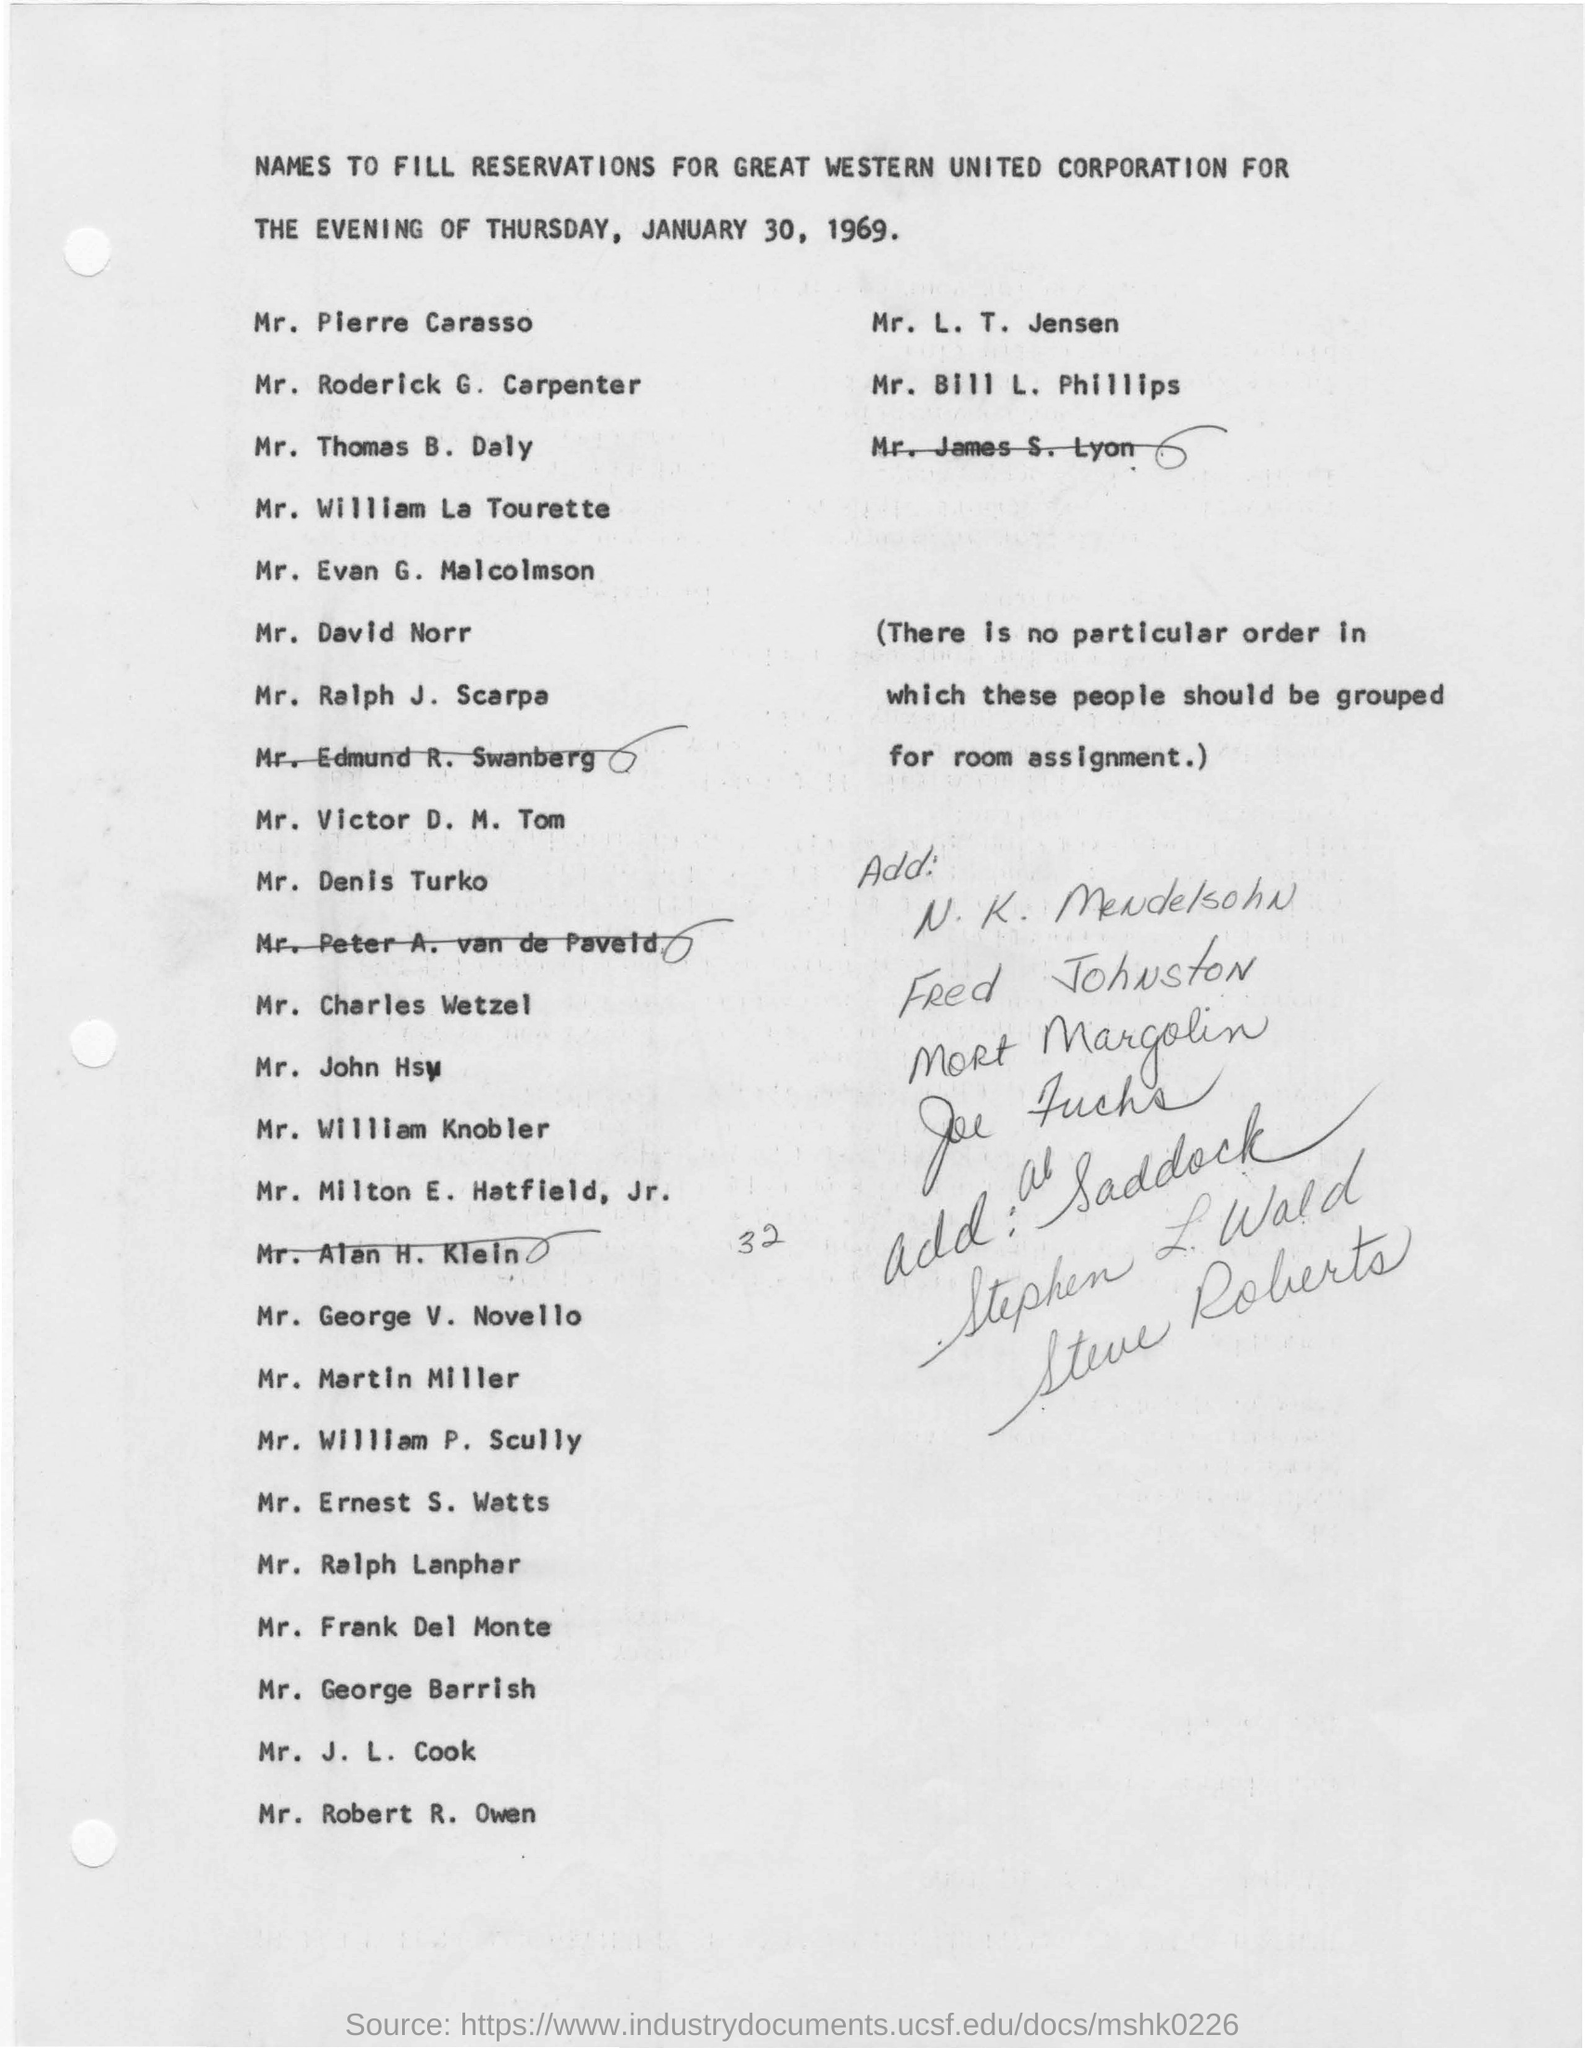What is the purpose of the letter?
Your answer should be very brief. NAMES TO FILL RESERVATIONS FOR GREAT WESTERN UNITED CORPORATION FOR THE EVENING OF THURSDAY, JANUARY 30, 1969. 